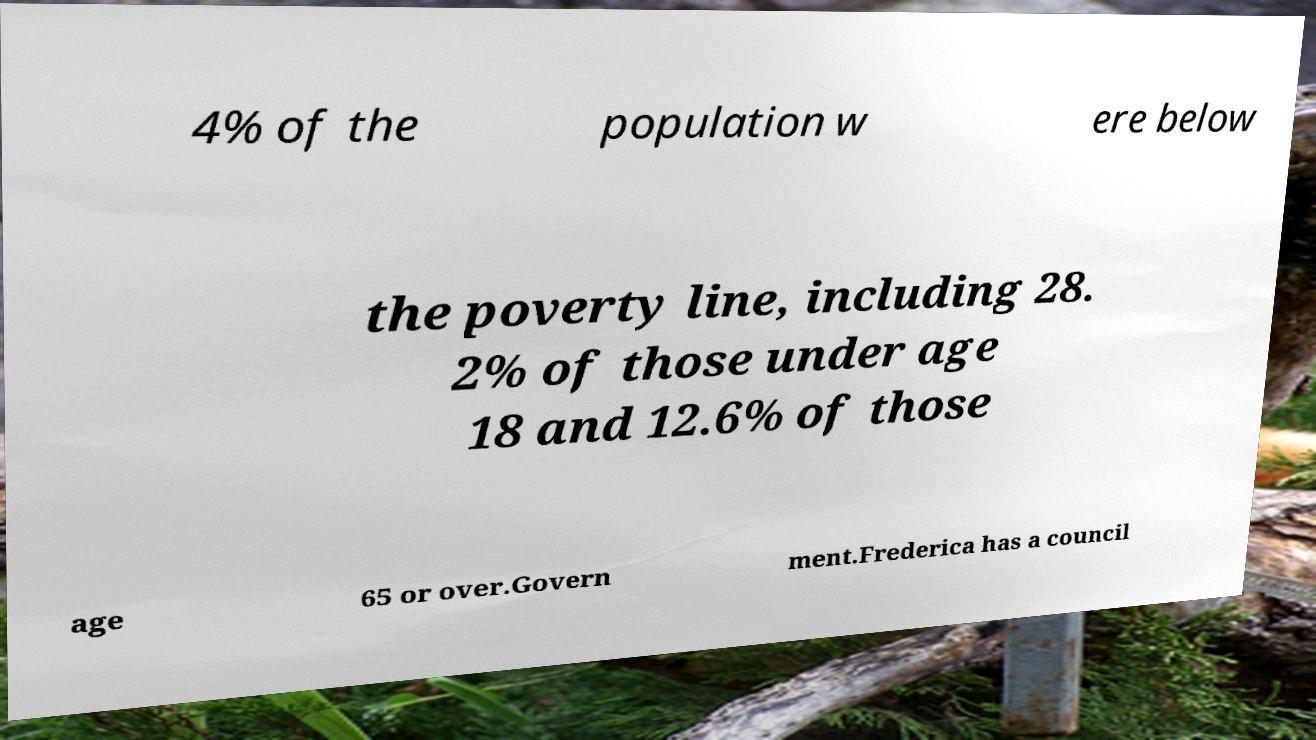There's text embedded in this image that I need extracted. Can you transcribe it verbatim? 4% of the population w ere below the poverty line, including 28. 2% of those under age 18 and 12.6% of those age 65 or over.Govern ment.Frederica has a council 